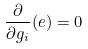<formula> <loc_0><loc_0><loc_500><loc_500>\frac { \partial } { \partial g _ { i } } ( e ) = 0</formula> 